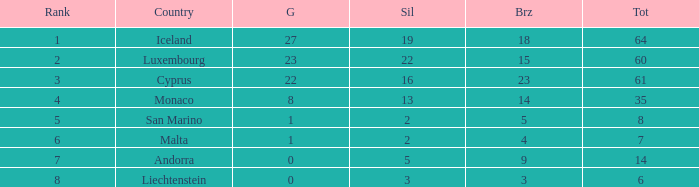How many golds for the nation with 14 total? 0.0. 